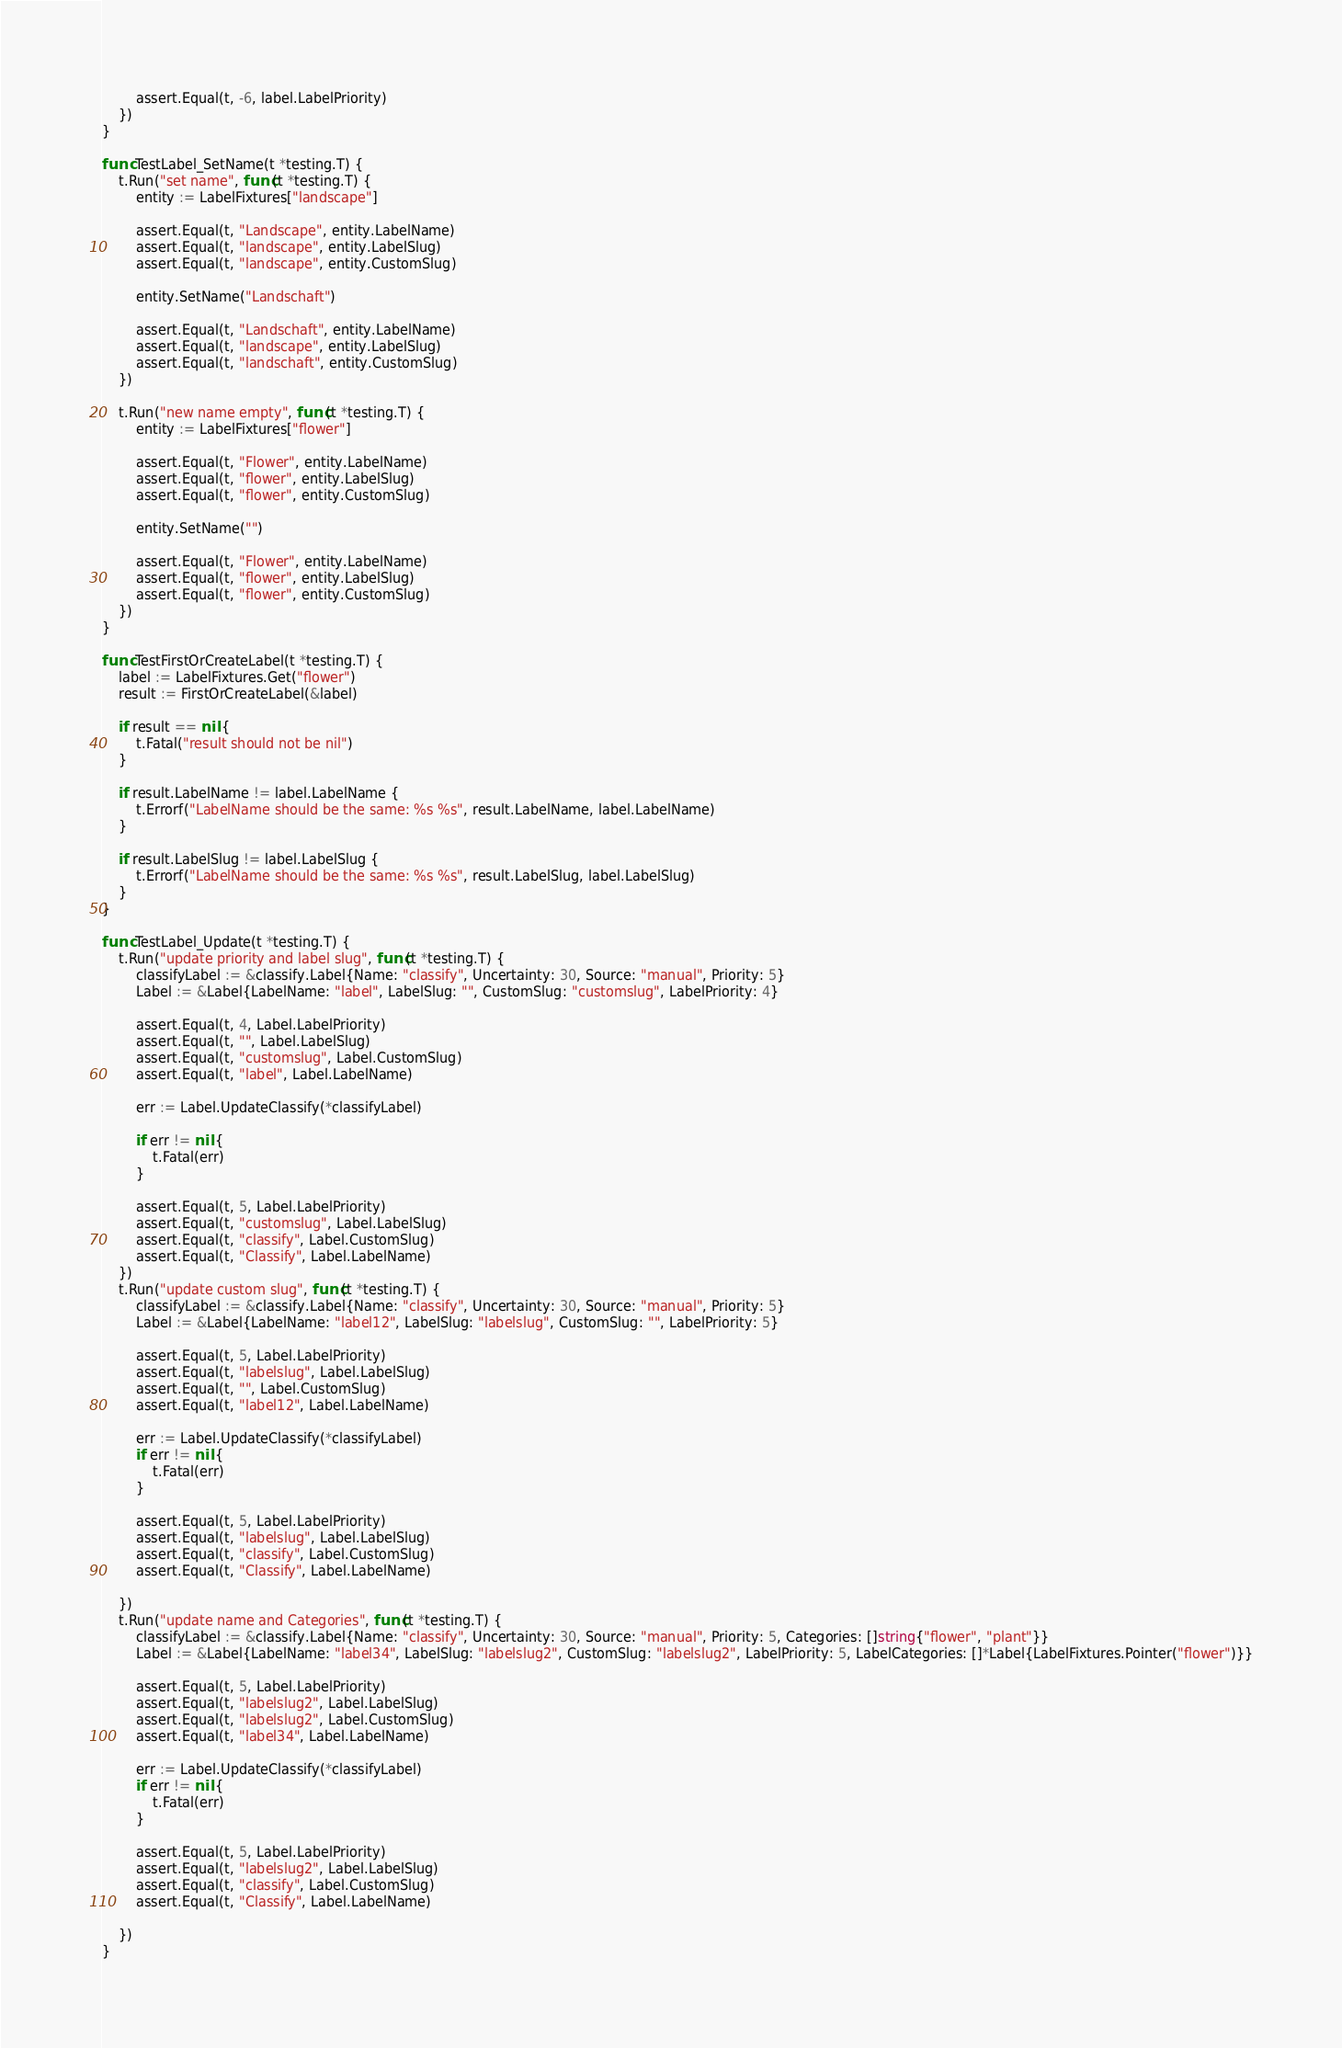<code> <loc_0><loc_0><loc_500><loc_500><_Go_>		assert.Equal(t, -6, label.LabelPriority)
	})
}

func TestLabel_SetName(t *testing.T) {
	t.Run("set name", func(t *testing.T) {
		entity := LabelFixtures["landscape"]

		assert.Equal(t, "Landscape", entity.LabelName)
		assert.Equal(t, "landscape", entity.LabelSlug)
		assert.Equal(t, "landscape", entity.CustomSlug)

		entity.SetName("Landschaft")

		assert.Equal(t, "Landschaft", entity.LabelName)
		assert.Equal(t, "landscape", entity.LabelSlug)
		assert.Equal(t, "landschaft", entity.CustomSlug)
	})

	t.Run("new name empty", func(t *testing.T) {
		entity := LabelFixtures["flower"]

		assert.Equal(t, "Flower", entity.LabelName)
		assert.Equal(t, "flower", entity.LabelSlug)
		assert.Equal(t, "flower", entity.CustomSlug)

		entity.SetName("")

		assert.Equal(t, "Flower", entity.LabelName)
		assert.Equal(t, "flower", entity.LabelSlug)
		assert.Equal(t, "flower", entity.CustomSlug)
	})
}

func TestFirstOrCreateLabel(t *testing.T) {
	label := LabelFixtures.Get("flower")
	result := FirstOrCreateLabel(&label)

	if result == nil {
		t.Fatal("result should not be nil")
	}

	if result.LabelName != label.LabelName {
		t.Errorf("LabelName should be the same: %s %s", result.LabelName, label.LabelName)
	}

	if result.LabelSlug != label.LabelSlug {
		t.Errorf("LabelName should be the same: %s %s", result.LabelSlug, label.LabelSlug)
	}
}

func TestLabel_Update(t *testing.T) {
	t.Run("update priority and label slug", func(t *testing.T) {
		classifyLabel := &classify.Label{Name: "classify", Uncertainty: 30, Source: "manual", Priority: 5}
		Label := &Label{LabelName: "label", LabelSlug: "", CustomSlug: "customslug", LabelPriority: 4}

		assert.Equal(t, 4, Label.LabelPriority)
		assert.Equal(t, "", Label.LabelSlug)
		assert.Equal(t, "customslug", Label.CustomSlug)
		assert.Equal(t, "label", Label.LabelName)

		err := Label.UpdateClassify(*classifyLabel)

		if err != nil {
			t.Fatal(err)
		}

		assert.Equal(t, 5, Label.LabelPriority)
		assert.Equal(t, "customslug", Label.LabelSlug)
		assert.Equal(t, "classify", Label.CustomSlug)
		assert.Equal(t, "Classify", Label.LabelName)
	})
	t.Run("update custom slug", func(t *testing.T) {
		classifyLabel := &classify.Label{Name: "classify", Uncertainty: 30, Source: "manual", Priority: 5}
		Label := &Label{LabelName: "label12", LabelSlug: "labelslug", CustomSlug: "", LabelPriority: 5}

		assert.Equal(t, 5, Label.LabelPriority)
		assert.Equal(t, "labelslug", Label.LabelSlug)
		assert.Equal(t, "", Label.CustomSlug)
		assert.Equal(t, "label12", Label.LabelName)

		err := Label.UpdateClassify(*classifyLabel)
		if err != nil {
			t.Fatal(err)
		}

		assert.Equal(t, 5, Label.LabelPriority)
		assert.Equal(t, "labelslug", Label.LabelSlug)
		assert.Equal(t, "classify", Label.CustomSlug)
		assert.Equal(t, "Classify", Label.LabelName)

	})
	t.Run("update name and Categories", func(t *testing.T) {
		classifyLabel := &classify.Label{Name: "classify", Uncertainty: 30, Source: "manual", Priority: 5, Categories: []string{"flower", "plant"}}
		Label := &Label{LabelName: "label34", LabelSlug: "labelslug2", CustomSlug: "labelslug2", LabelPriority: 5, LabelCategories: []*Label{LabelFixtures.Pointer("flower")}}

		assert.Equal(t, 5, Label.LabelPriority)
		assert.Equal(t, "labelslug2", Label.LabelSlug)
		assert.Equal(t, "labelslug2", Label.CustomSlug)
		assert.Equal(t, "label34", Label.LabelName)

		err := Label.UpdateClassify(*classifyLabel)
		if err != nil {
			t.Fatal(err)
		}

		assert.Equal(t, 5, Label.LabelPriority)
		assert.Equal(t, "labelslug2", Label.LabelSlug)
		assert.Equal(t, "classify", Label.CustomSlug)
		assert.Equal(t, "Classify", Label.LabelName)

	})
}
</code> 